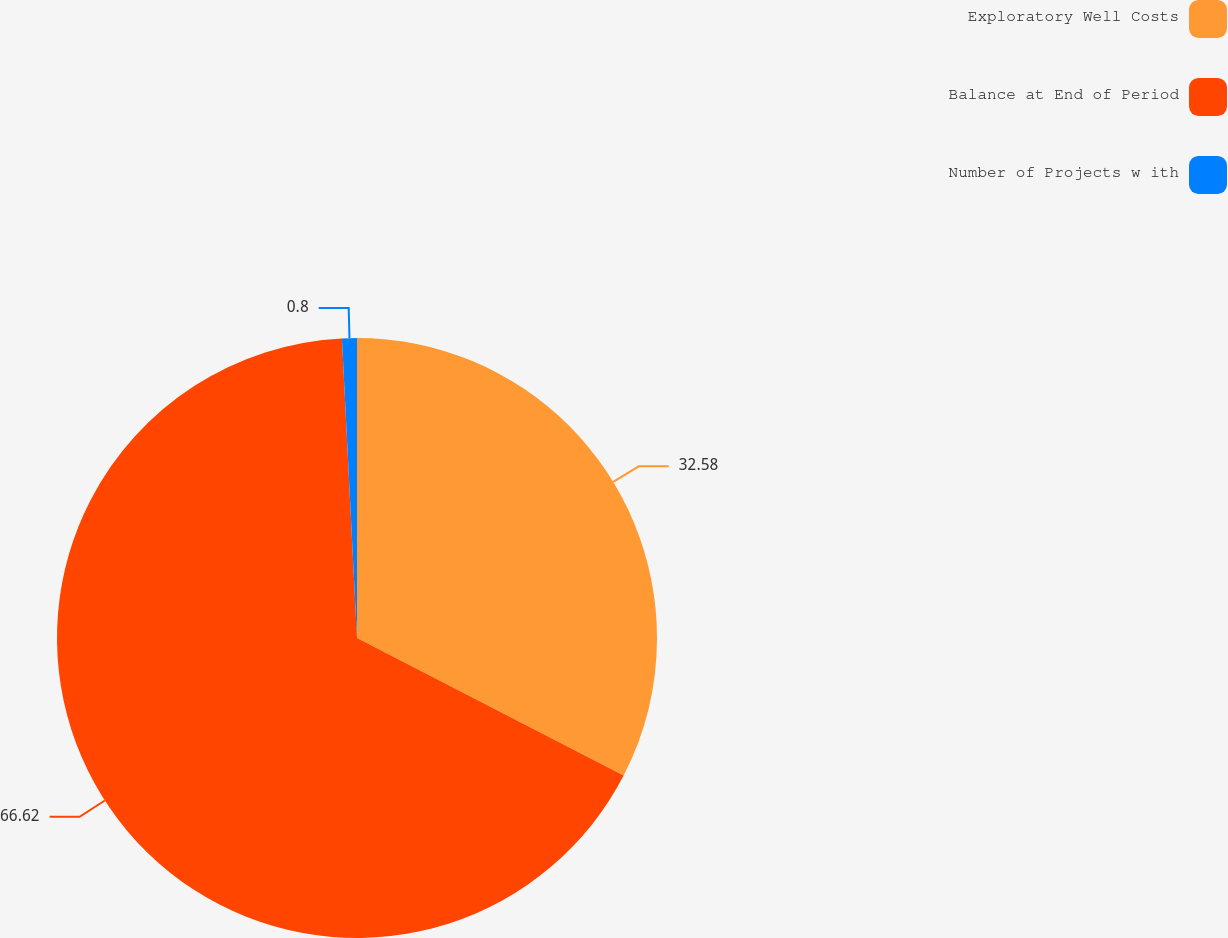<chart> <loc_0><loc_0><loc_500><loc_500><pie_chart><fcel>Exploratory Well Costs<fcel>Balance at End of Period<fcel>Number of Projects w ith<nl><fcel>32.58%<fcel>66.62%<fcel>0.8%<nl></chart> 